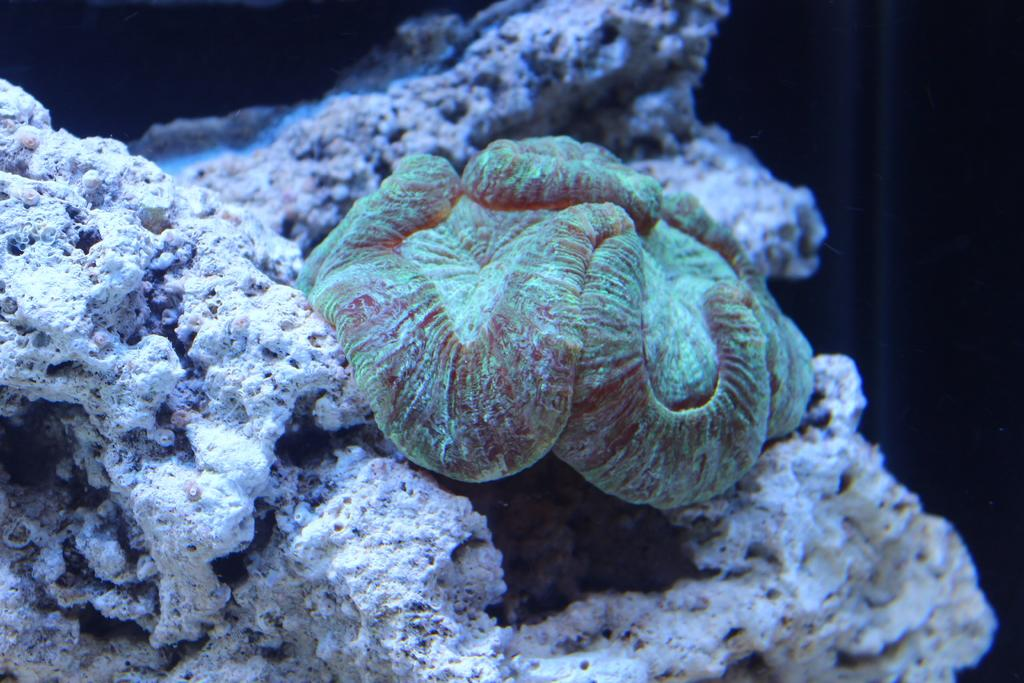What type of coral is visible in the image? There is open brain coral in the image. What other objects can be seen in the image? Rocks are visible in the image. Where are the coral and rocks located? The coral and rocks are underwater. What is the level of noise in the downtown area in the image? There is no reference to a downtown area or noise level in the image, as it features underwater coral and rocks. 